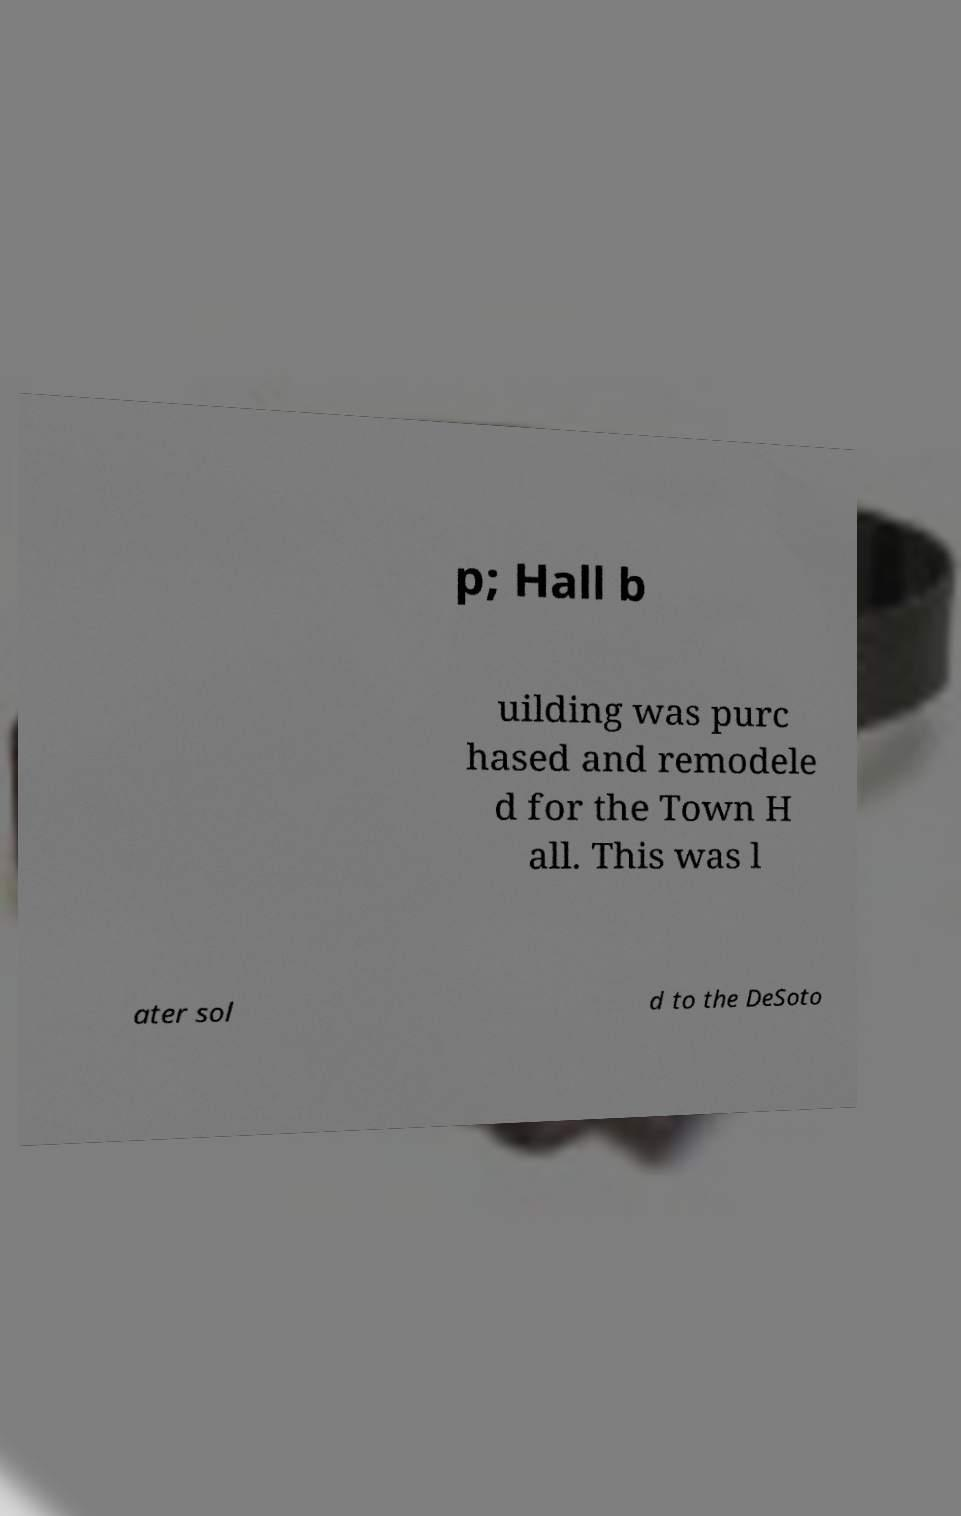Please read and relay the text visible in this image. What does it say? p; Hall b uilding was purc hased and remodele d for the Town H all. This was l ater sol d to the DeSoto 